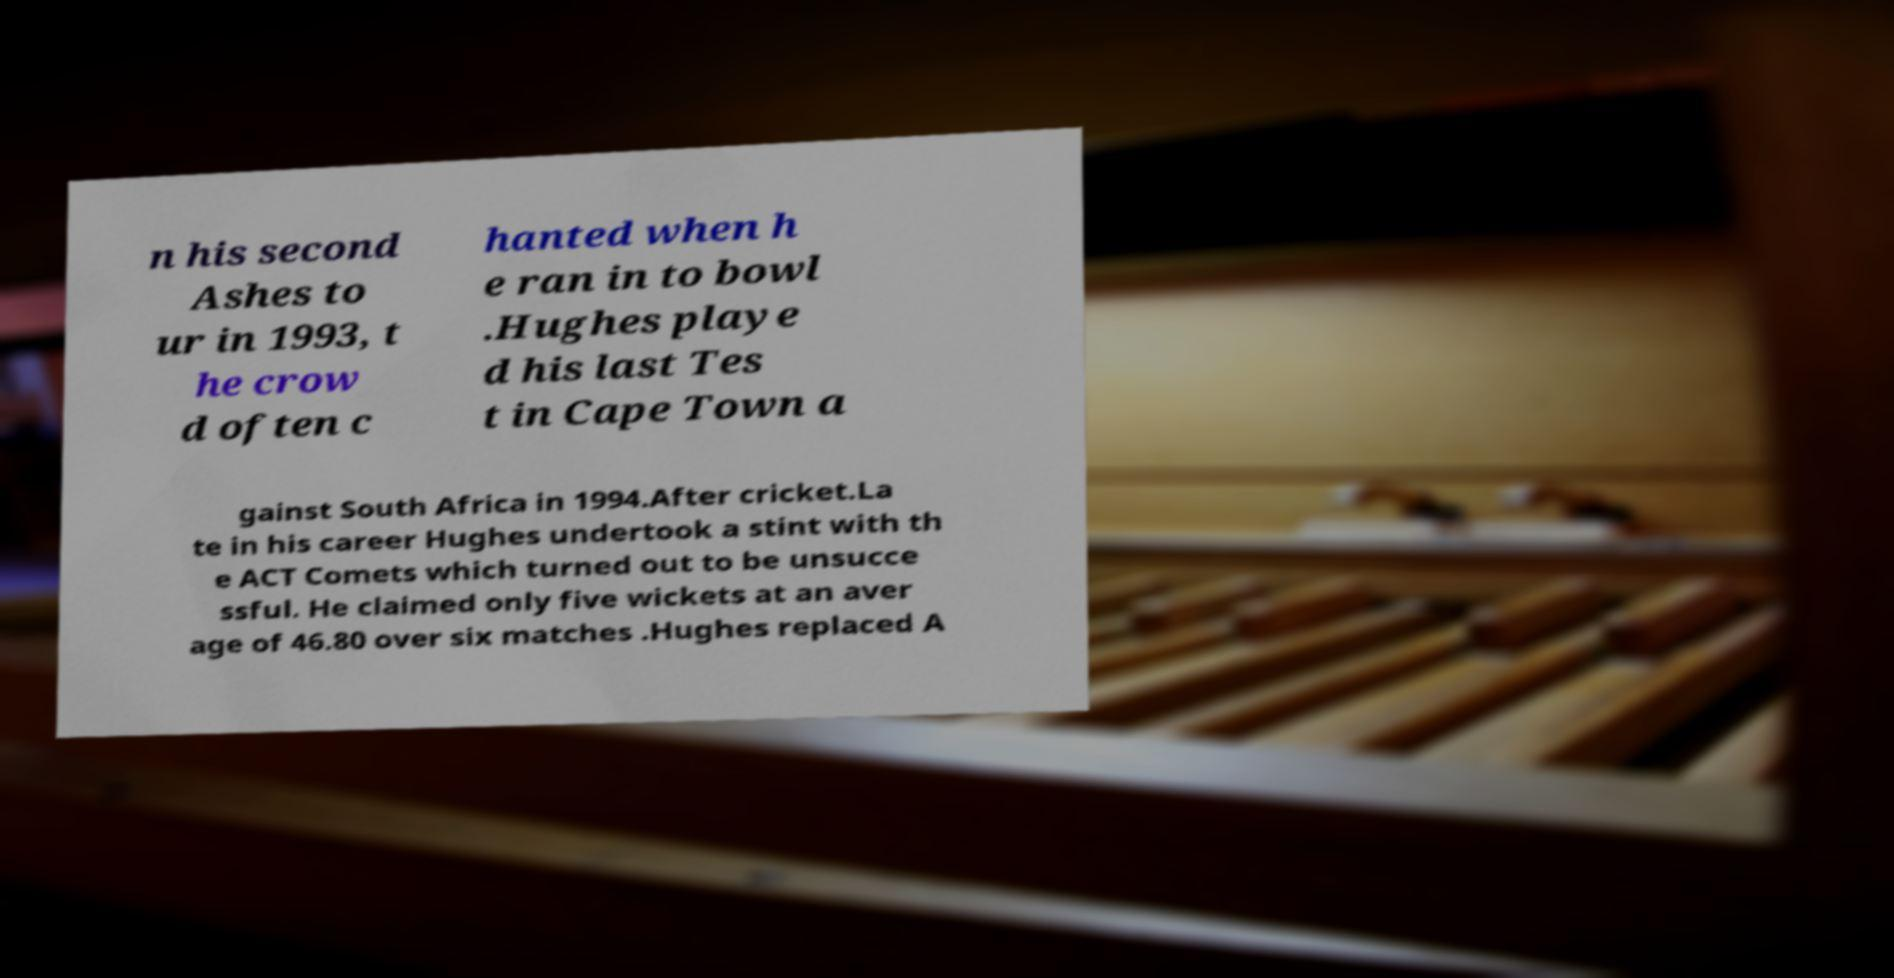Can you accurately transcribe the text from the provided image for me? n his second Ashes to ur in 1993, t he crow d often c hanted when h e ran in to bowl .Hughes playe d his last Tes t in Cape Town a gainst South Africa in 1994.After cricket.La te in his career Hughes undertook a stint with th e ACT Comets which turned out to be unsucce ssful. He claimed only five wickets at an aver age of 46.80 over six matches .Hughes replaced A 